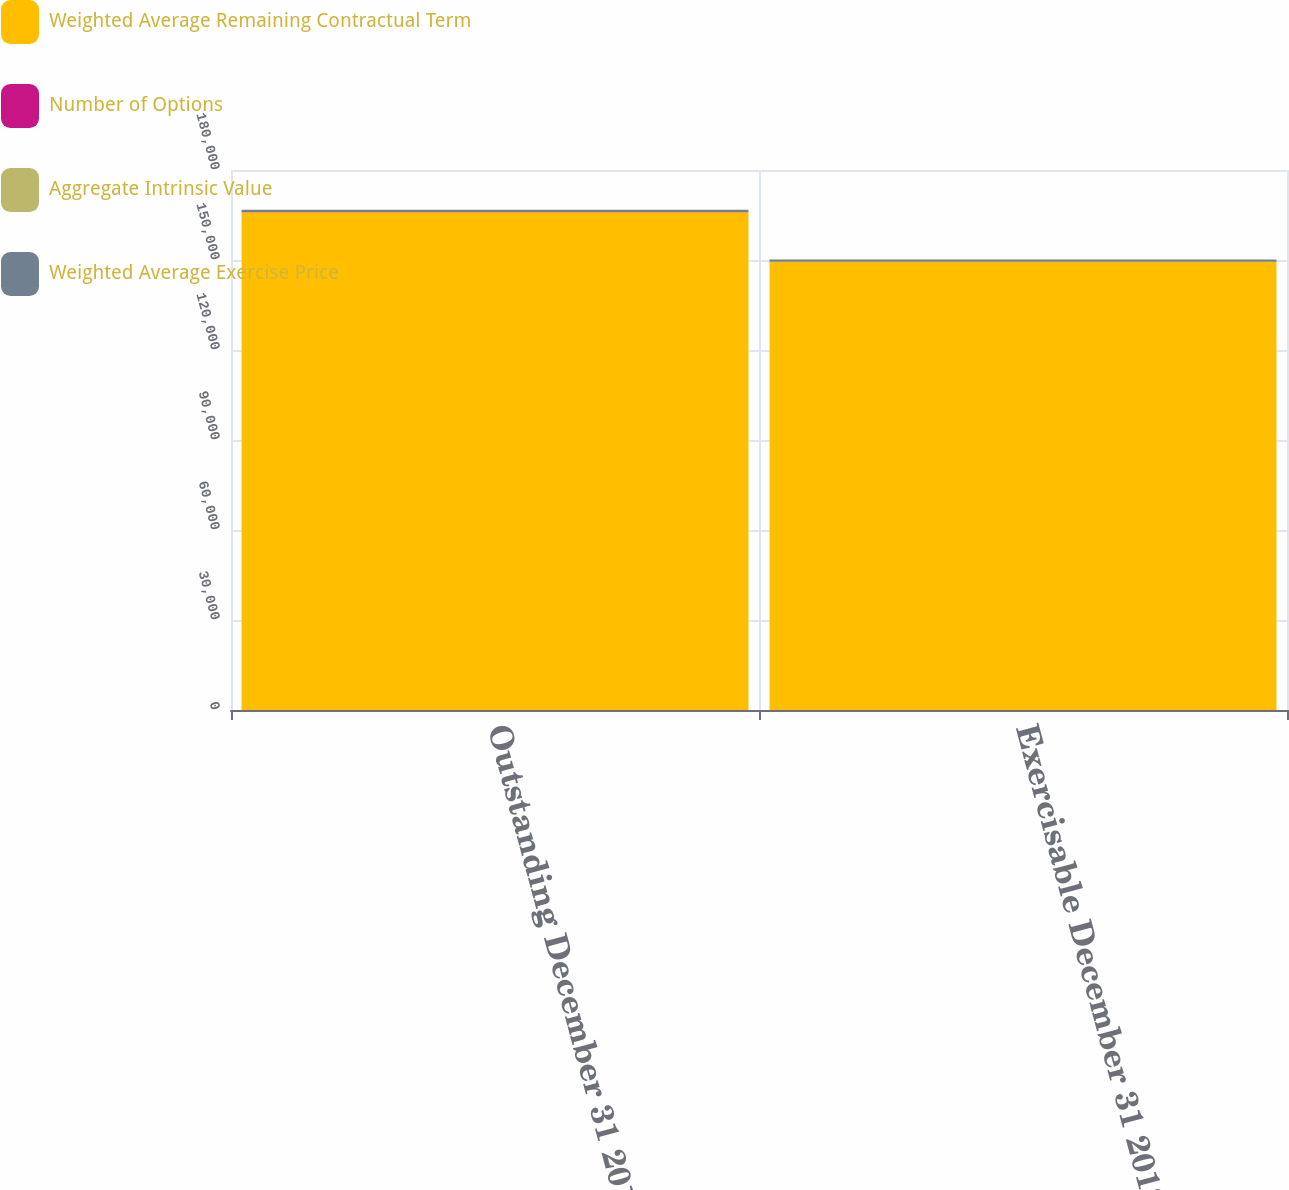Convert chart to OTSL. <chart><loc_0><loc_0><loc_500><loc_500><stacked_bar_chart><ecel><fcel>Outstanding December 31 2012<fcel>Exercisable December 31 2012<nl><fcel>Weighted Average Remaining Contractual Term<fcel>165941<fcel>149407<nl><fcel>Number of Options<fcel>39.46<fcel>39.64<nl><fcel>Aggregate Intrinsic Value<fcel>3.9<fcel>3.45<nl><fcel>Weighted Average Exercise Price<fcel>762<fcel>700<nl></chart> 